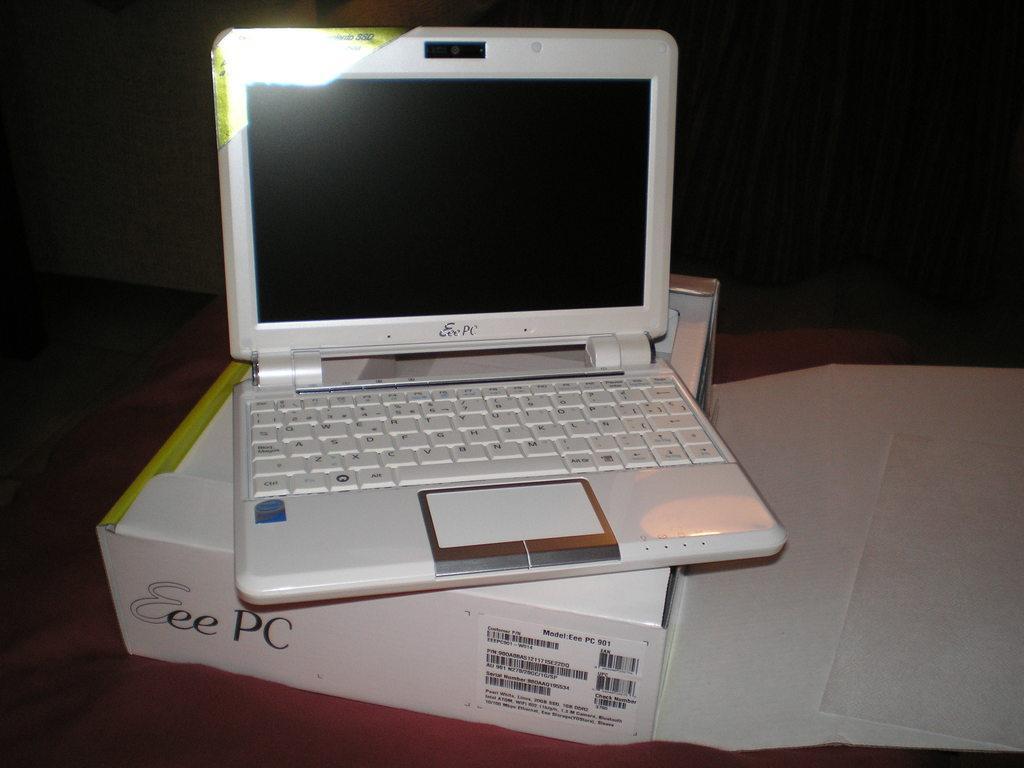Please provide a concise description of this image. Here in this picture we can see a laptop present on a box, which is present on a table. 